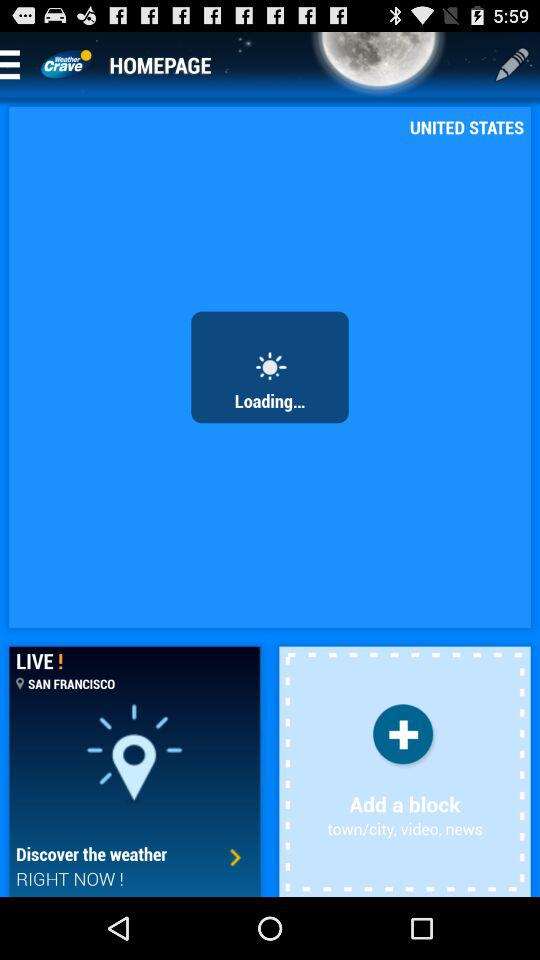What is the city name? The city name is San Francisco. 